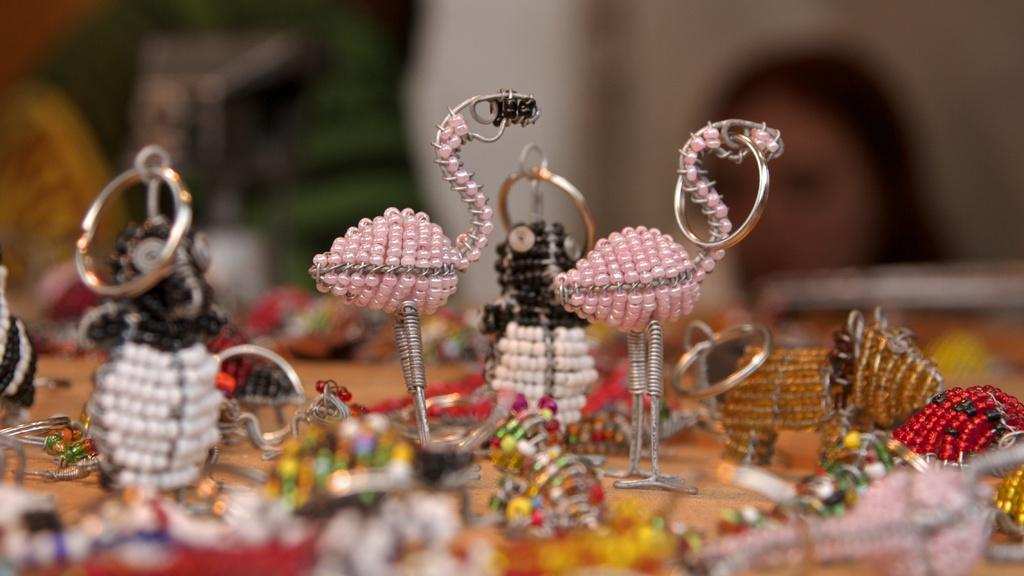What type of toys are present in the image? There are many toys made up of steel and pearl in the image. Can you describe the person visible in the image? Unfortunately, the facts provided do not give any details about the person in the image. What can be said about the background of the image? The background of the image is blurred. What type of hair can be seen on the pickle in the image? There is no pickle present in the image, and therefore no hair can be seen on it. 